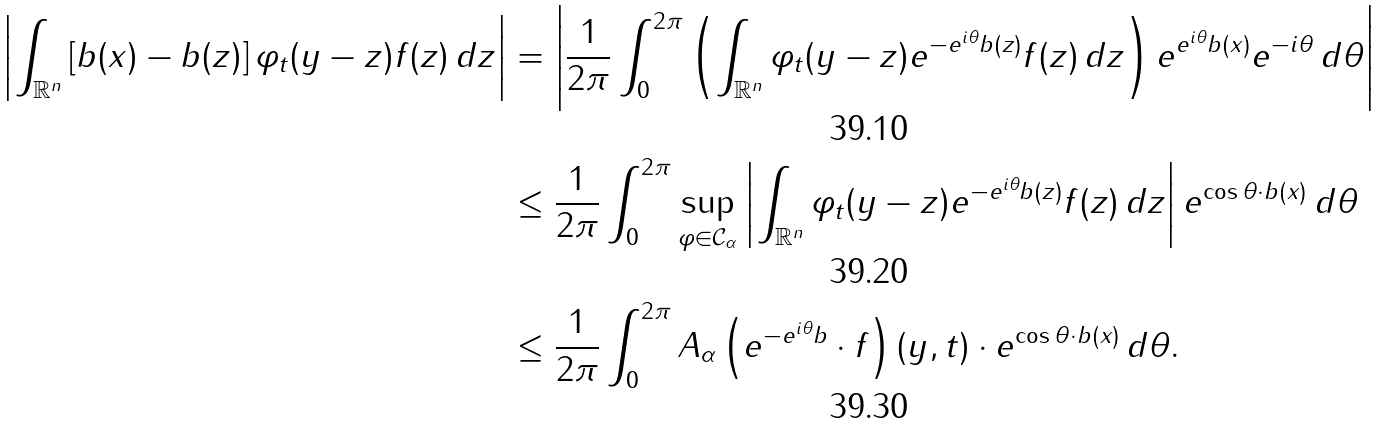Convert formula to latex. <formula><loc_0><loc_0><loc_500><loc_500>\left | \int _ { \mathbb { R } ^ { n } } \left [ b ( x ) - b ( z ) \right ] \varphi _ { t } ( y - z ) f ( z ) \, d z \right | & = \left | \frac { 1 } { 2 \pi } \int _ { 0 } ^ { 2 \pi } \left ( \int _ { \mathbb { R } ^ { n } } \varphi _ { t } ( y - z ) e ^ { - e ^ { i \theta } b ( z ) } f ( z ) \, d z \right ) e ^ { e ^ { i \theta } b ( x ) } e ^ { - i \theta } \, d \theta \right | \\ & \leq \frac { 1 } { 2 \pi } \int _ { 0 } ^ { 2 \pi } \sup _ { \varphi \in { \mathcal { C } } _ { \alpha } } \left | \int _ { \mathbb { R } ^ { n } } \varphi _ { t } ( y - z ) e ^ { - e ^ { i \theta } b ( z ) } f ( z ) \, d z \right | e ^ { \cos \theta \cdot b ( x ) } \, d \theta \\ & \leq \frac { 1 } { 2 \pi } \int _ { 0 } ^ { 2 \pi } A _ { \alpha } \left ( e ^ { - e ^ { i \theta } b } \cdot f \right ) ( y , t ) \cdot e ^ { \cos \theta \cdot b ( x ) } \, d \theta .</formula> 